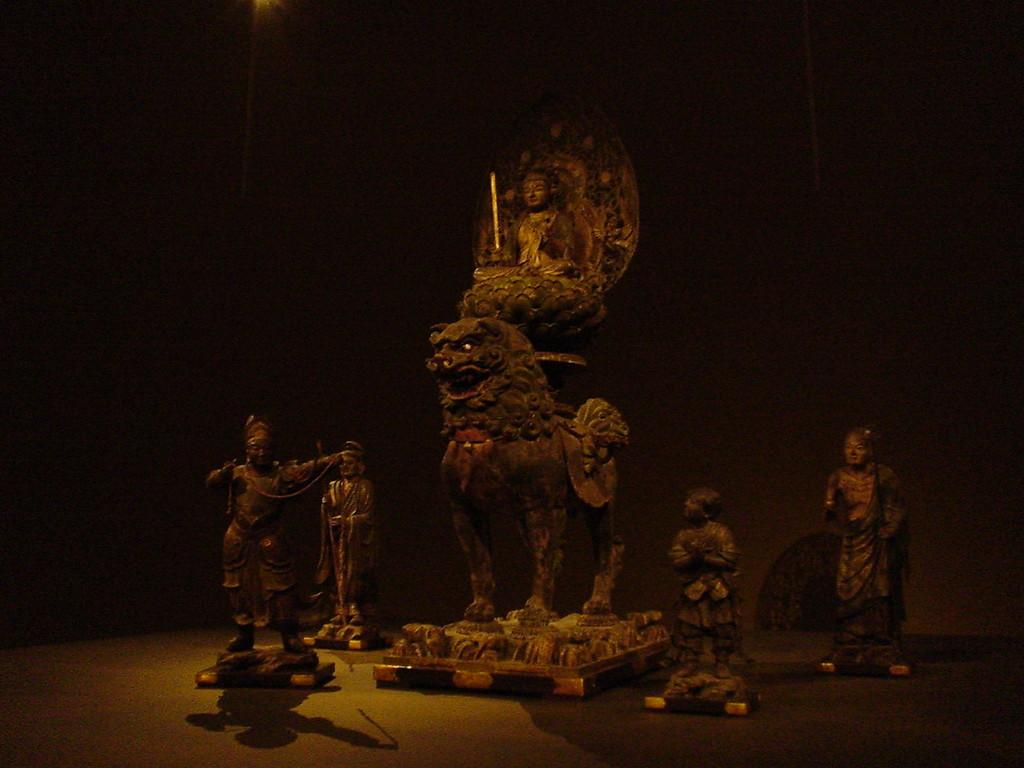What type of objects are present in the image? There are small statues in the image. Can you describe the central statue in the image? A: There is a statue with Buddha in the middle. How many statues surround the central statue? There are four statues surrounding the central statue. What type of clam is used as a base for the central statue? There is no clam present in the image; the central statue is a statue with Buddha. What type of pot is used to hold the surrounding statues? There is no pot present in the image; the surrounding statues are placed around the central statue without any pot. 